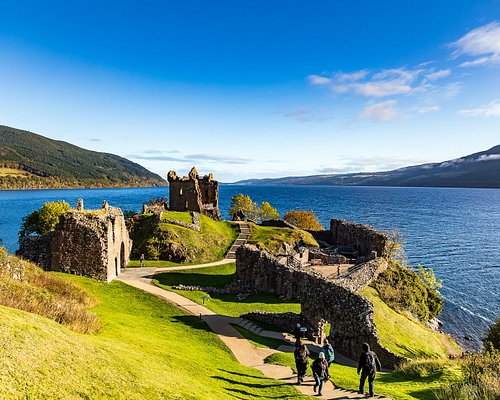Describe the following image. The image captures the majestic ruins of Urquhart Castle, a historical landmark nestled on the verdant banks of Loch Ness in Scotland. The castle, constructed from stone, stands on a grassy hill, offering a panoramic view of the loch. Time has left its mark on the castle, with vegetation partially covering the stone ruins, blending the man-made structure with the natural landscape. The sky above is a clear blue, mirroring the deep blue-green hue of the water below. A winding path leads up to the castle, inviting visitors to explore its history and enjoy the breathtaking view. A few people can be seen walking on the path, adding a touch of life to the serene scene. 